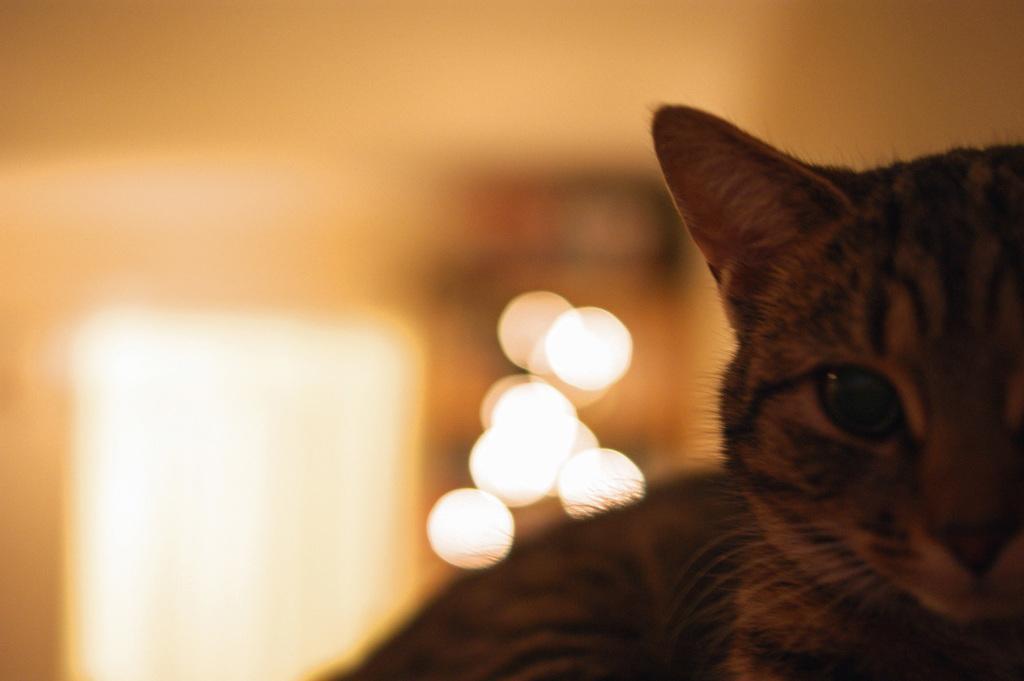Can you describe this image briefly? In this image, we can see a cat. Background there is a blur view. 